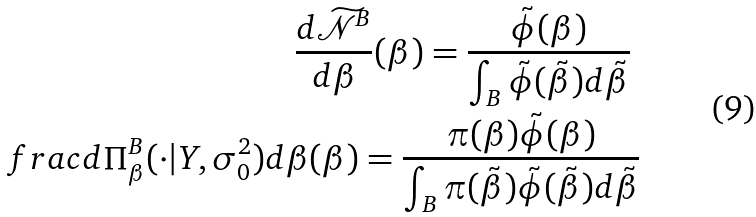Convert formula to latex. <formula><loc_0><loc_0><loc_500><loc_500>\frac { d \widetilde { \mathcal { N } } ^ { B } } { d \beta } ( \beta ) = \frac { \tilde { \phi } ( \beta ) } { \int _ { B } \tilde { \phi } ( \tilde { \beta } ) d \tilde { \beta } } \ \\ f r a c { d \Pi _ { \beta } ^ { B } ( \cdot | Y , \sigma _ { 0 } ^ { 2 } ) } { d \beta } ( \beta ) = \frac { \pi ( \beta ) \tilde { \phi } ( \beta ) } { \int _ { B } \pi ( \tilde { \beta } ) \tilde { \phi } ( \tilde { \beta } ) d \tilde { \beta } }</formula> 